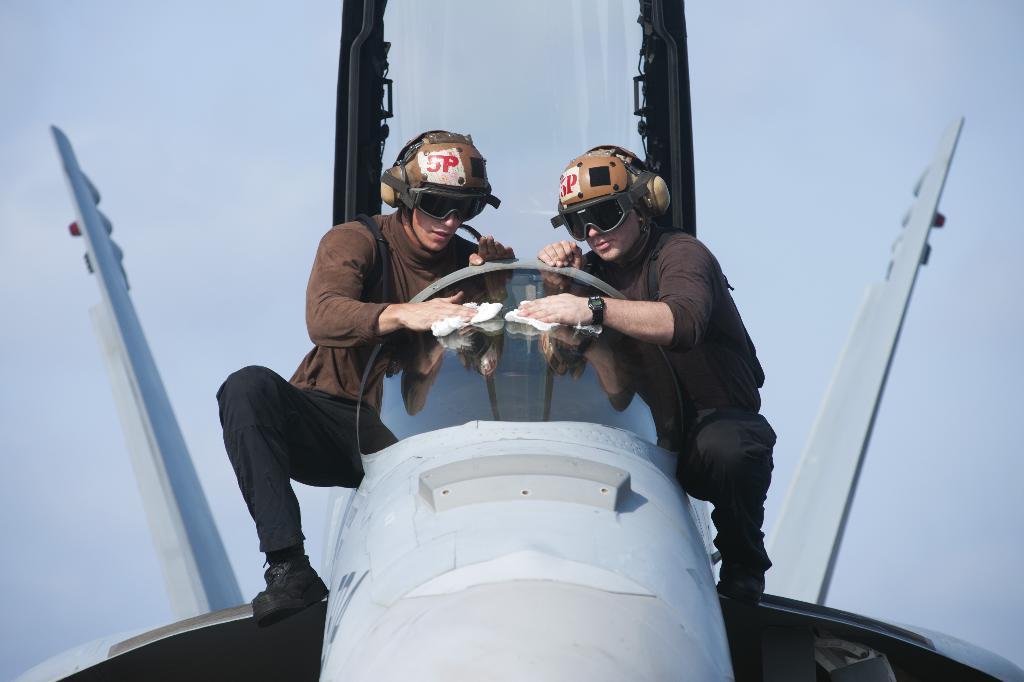Could you give a brief overview of what you see in this image? In the foreground of this picture, there is an airplane on which two men standing and cleaning the glass with white colored cloth. In the background, there is the sky. 